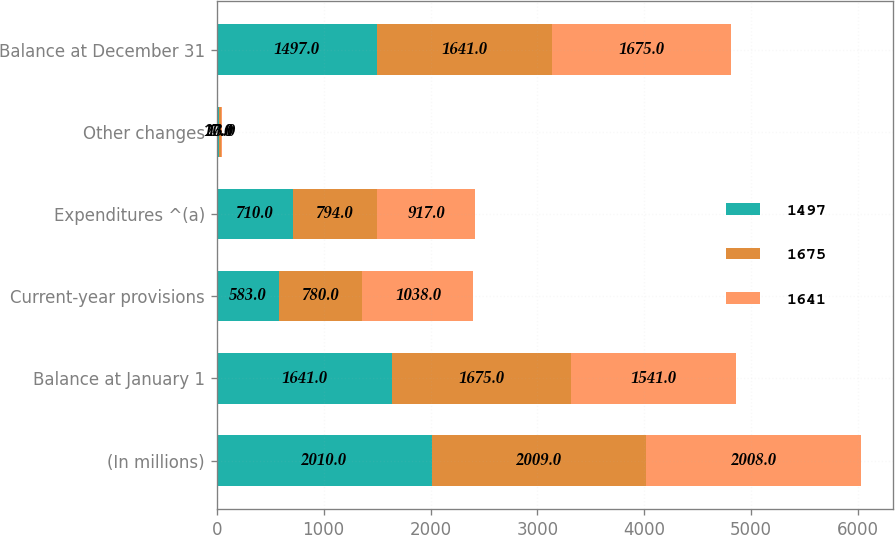<chart> <loc_0><loc_0><loc_500><loc_500><stacked_bar_chart><ecel><fcel>(In millions)<fcel>Balance at January 1<fcel>Current-year provisions<fcel>Expenditures ^(a)<fcel>Other changes<fcel>Balance at December 31<nl><fcel>1497<fcel>2010<fcel>1641<fcel>583<fcel>710<fcel>17<fcel>1497<nl><fcel>1675<fcel>2009<fcel>1675<fcel>780<fcel>794<fcel>20<fcel>1641<nl><fcel>1641<fcel>2008<fcel>1541<fcel>1038<fcel>917<fcel>13<fcel>1675<nl></chart> 